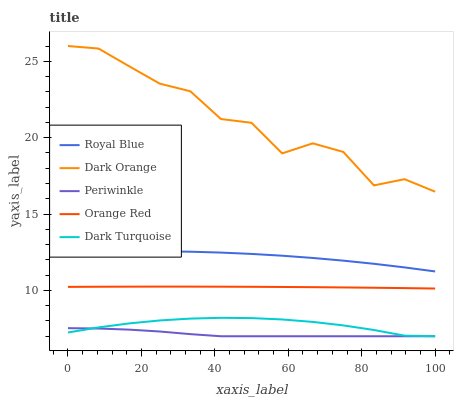Does Periwinkle have the minimum area under the curve?
Answer yes or no. Yes. Does Dark Orange have the maximum area under the curve?
Answer yes or no. Yes. Does Orange Red have the minimum area under the curve?
Answer yes or no. No. Does Orange Red have the maximum area under the curve?
Answer yes or no. No. Is Orange Red the smoothest?
Answer yes or no. Yes. Is Dark Orange the roughest?
Answer yes or no. Yes. Is Periwinkle the smoothest?
Answer yes or no. No. Is Periwinkle the roughest?
Answer yes or no. No. Does Periwinkle have the lowest value?
Answer yes or no. Yes. Does Orange Red have the lowest value?
Answer yes or no. No. Does Dark Orange have the highest value?
Answer yes or no. Yes. Does Orange Red have the highest value?
Answer yes or no. No. Is Orange Red less than Dark Orange?
Answer yes or no. Yes. Is Royal Blue greater than Dark Turquoise?
Answer yes or no. Yes. Does Dark Turquoise intersect Periwinkle?
Answer yes or no. Yes. Is Dark Turquoise less than Periwinkle?
Answer yes or no. No. Is Dark Turquoise greater than Periwinkle?
Answer yes or no. No. Does Orange Red intersect Dark Orange?
Answer yes or no. No. 